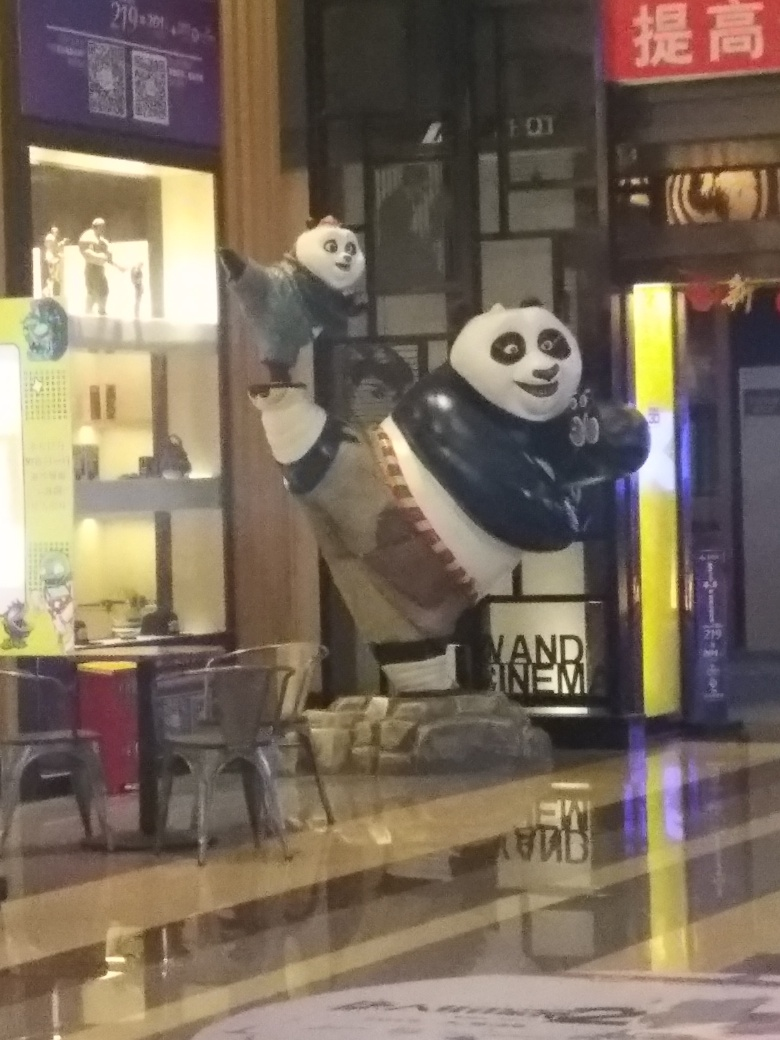Are the details well-preserved in the focal point? The focus is on the depiction of pandas in what appears to be an advertising figure. The details of the image are somewhat obscured due to the lighting and reflections on the floor, which detracts from the sharpness and clarity that would ideally preserve the details in the focal area. 